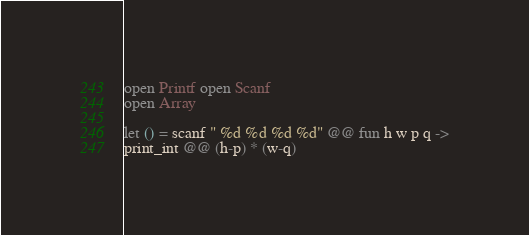<code> <loc_0><loc_0><loc_500><loc_500><_OCaml_>open Printf open Scanf
open Array

let () = scanf " %d %d %d %d" @@ fun h w p q ->
print_int @@ (h-p) * (w-q)</code> 